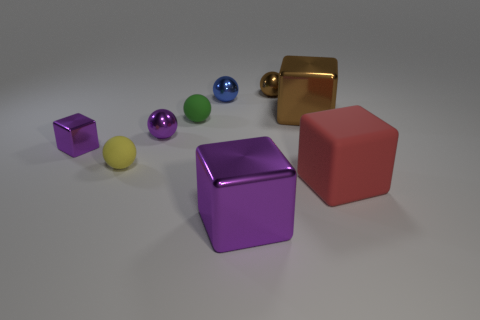There is a small metal thing that is the same shape as the large purple metal thing; what is its color?
Offer a very short reply. Purple. Do the object in front of the matte cube and the tiny metallic block have the same color?
Your response must be concise. Yes. The brown thing that is the same shape as the large red rubber thing is what size?
Provide a succinct answer. Large. What number of small things have the same color as the big rubber cube?
Offer a very short reply. 0. There is a metallic thing that is right of the blue metallic object and behind the brown cube; what shape is it?
Ensure brevity in your answer.  Sphere. The rubber object that is left of the matte cube and in front of the green thing is what color?
Provide a short and direct response. Yellow. Is the number of purple metallic objects right of the small purple ball greater than the number of big objects that are behind the tiny brown metal thing?
Provide a succinct answer. Yes. What is the color of the big metallic object to the left of the brown metal ball?
Provide a succinct answer. Purple. There is a tiny purple thing that is on the right side of the yellow matte sphere; is its shape the same as the purple object in front of the small yellow thing?
Your answer should be compact. No. Are there any green balls of the same size as the yellow thing?
Make the answer very short. Yes. 